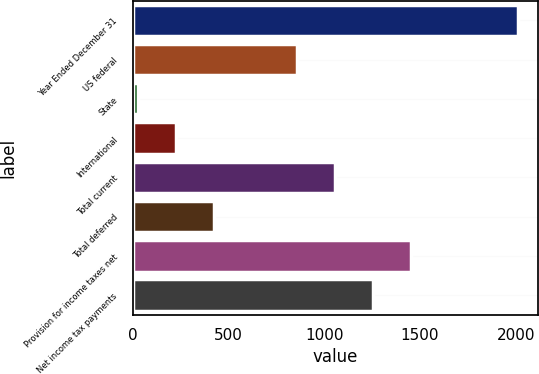Convert chart. <chart><loc_0><loc_0><loc_500><loc_500><bar_chart><fcel>Year Ended December 31<fcel>US federal<fcel>State<fcel>International<fcel>Total current<fcel>Total deferred<fcel>Provision for income taxes net<fcel>Net income tax payments<nl><fcel>2014<fcel>856<fcel>31<fcel>229.3<fcel>1054.3<fcel>427.6<fcel>1450.9<fcel>1252.6<nl></chart> 